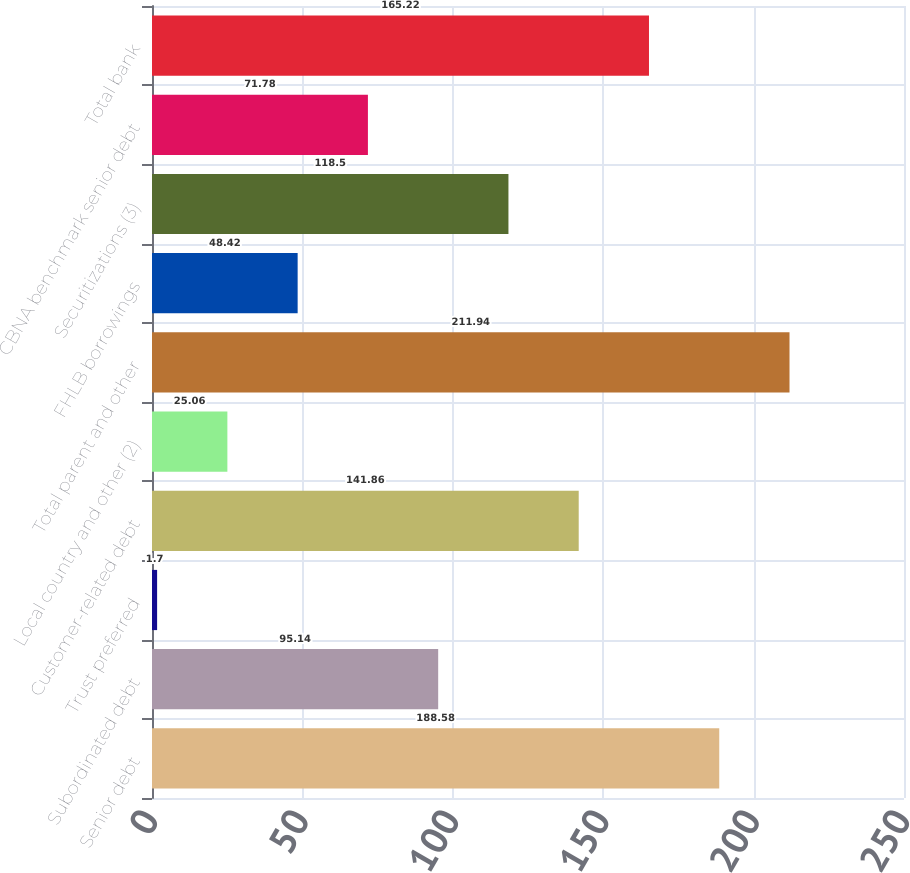Convert chart. <chart><loc_0><loc_0><loc_500><loc_500><bar_chart><fcel>Senior debt<fcel>Subordinated debt<fcel>Trust preferred<fcel>Customer-related debt<fcel>Local country and other (2)<fcel>Total parent and other<fcel>FHLB borrowings<fcel>Securitizations (3)<fcel>CBNA benchmark senior debt<fcel>Total bank<nl><fcel>188.58<fcel>95.14<fcel>1.7<fcel>141.86<fcel>25.06<fcel>211.94<fcel>48.42<fcel>118.5<fcel>71.78<fcel>165.22<nl></chart> 